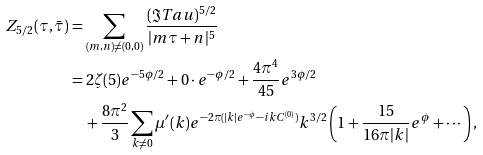<formula> <loc_0><loc_0><loc_500><loc_500>Z _ { 5 / 2 } ( \tau , \bar { \tau } ) & = \sum _ { ( m , n ) \neq ( 0 , 0 ) } \frac { ( \Im T a u ) ^ { 5 / 2 } } { | m \tau + n | ^ { 5 } } \\ & = 2 \zeta ( 5 ) e ^ { - 5 \phi / 2 } + 0 \cdot e ^ { - \phi / 2 } + \frac { 4 \pi ^ { 4 } } { 4 5 } e ^ { 3 \phi / 2 } \\ & \quad + \frac { 8 \pi ^ { 2 } } { 3 } \sum _ { k \neq 0 } \mu ^ { \prime } ( k ) e ^ { - 2 \pi ( | k | e ^ { - \phi } - i k C ^ { ( 0 ) } ) } k ^ { 3 / 2 } \left ( 1 + \frac { 1 5 } { 1 6 \pi | k | } e ^ { \phi } + \cdots \right ) ,</formula> 